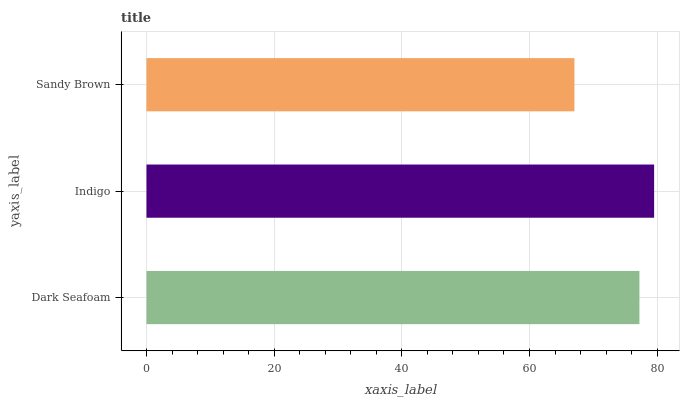Is Sandy Brown the minimum?
Answer yes or no. Yes. Is Indigo the maximum?
Answer yes or no. Yes. Is Indigo the minimum?
Answer yes or no. No. Is Sandy Brown the maximum?
Answer yes or no. No. Is Indigo greater than Sandy Brown?
Answer yes or no. Yes. Is Sandy Brown less than Indigo?
Answer yes or no. Yes. Is Sandy Brown greater than Indigo?
Answer yes or no. No. Is Indigo less than Sandy Brown?
Answer yes or no. No. Is Dark Seafoam the high median?
Answer yes or no. Yes. Is Dark Seafoam the low median?
Answer yes or no. Yes. Is Indigo the high median?
Answer yes or no. No. Is Indigo the low median?
Answer yes or no. No. 